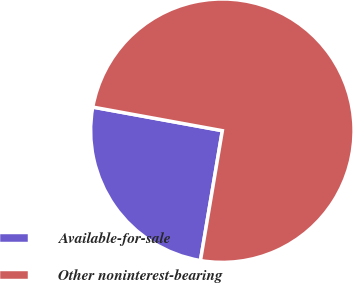Convert chart to OTSL. <chart><loc_0><loc_0><loc_500><loc_500><pie_chart><fcel>Available-for-sale<fcel>Other noninterest-bearing<nl><fcel>25.21%<fcel>74.79%<nl></chart> 